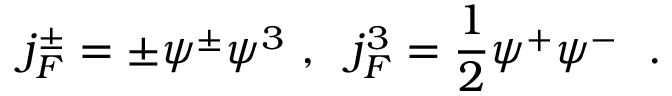<formula> <loc_0><loc_0><loc_500><loc_500>j _ { F } ^ { \pm } = \pm \psi ^ { \pm } \psi ^ { 3 } , j _ { F } ^ { 3 } = \frac { 1 } { 2 } \psi ^ { + } \psi ^ { - } .</formula> 